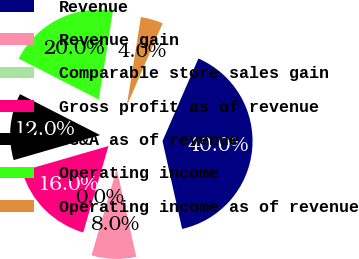<chart> <loc_0><loc_0><loc_500><loc_500><pie_chart><fcel>Revenue<fcel>Revenue gain<fcel>Comparable store sales gain<fcel>Gross profit as of revenue<fcel>SG&A as of revenue<fcel>Operating income<fcel>Operating income as of revenue<nl><fcel>39.99%<fcel>8.0%<fcel>0.01%<fcel>16.0%<fcel>12.0%<fcel>20.0%<fcel>4.01%<nl></chart> 